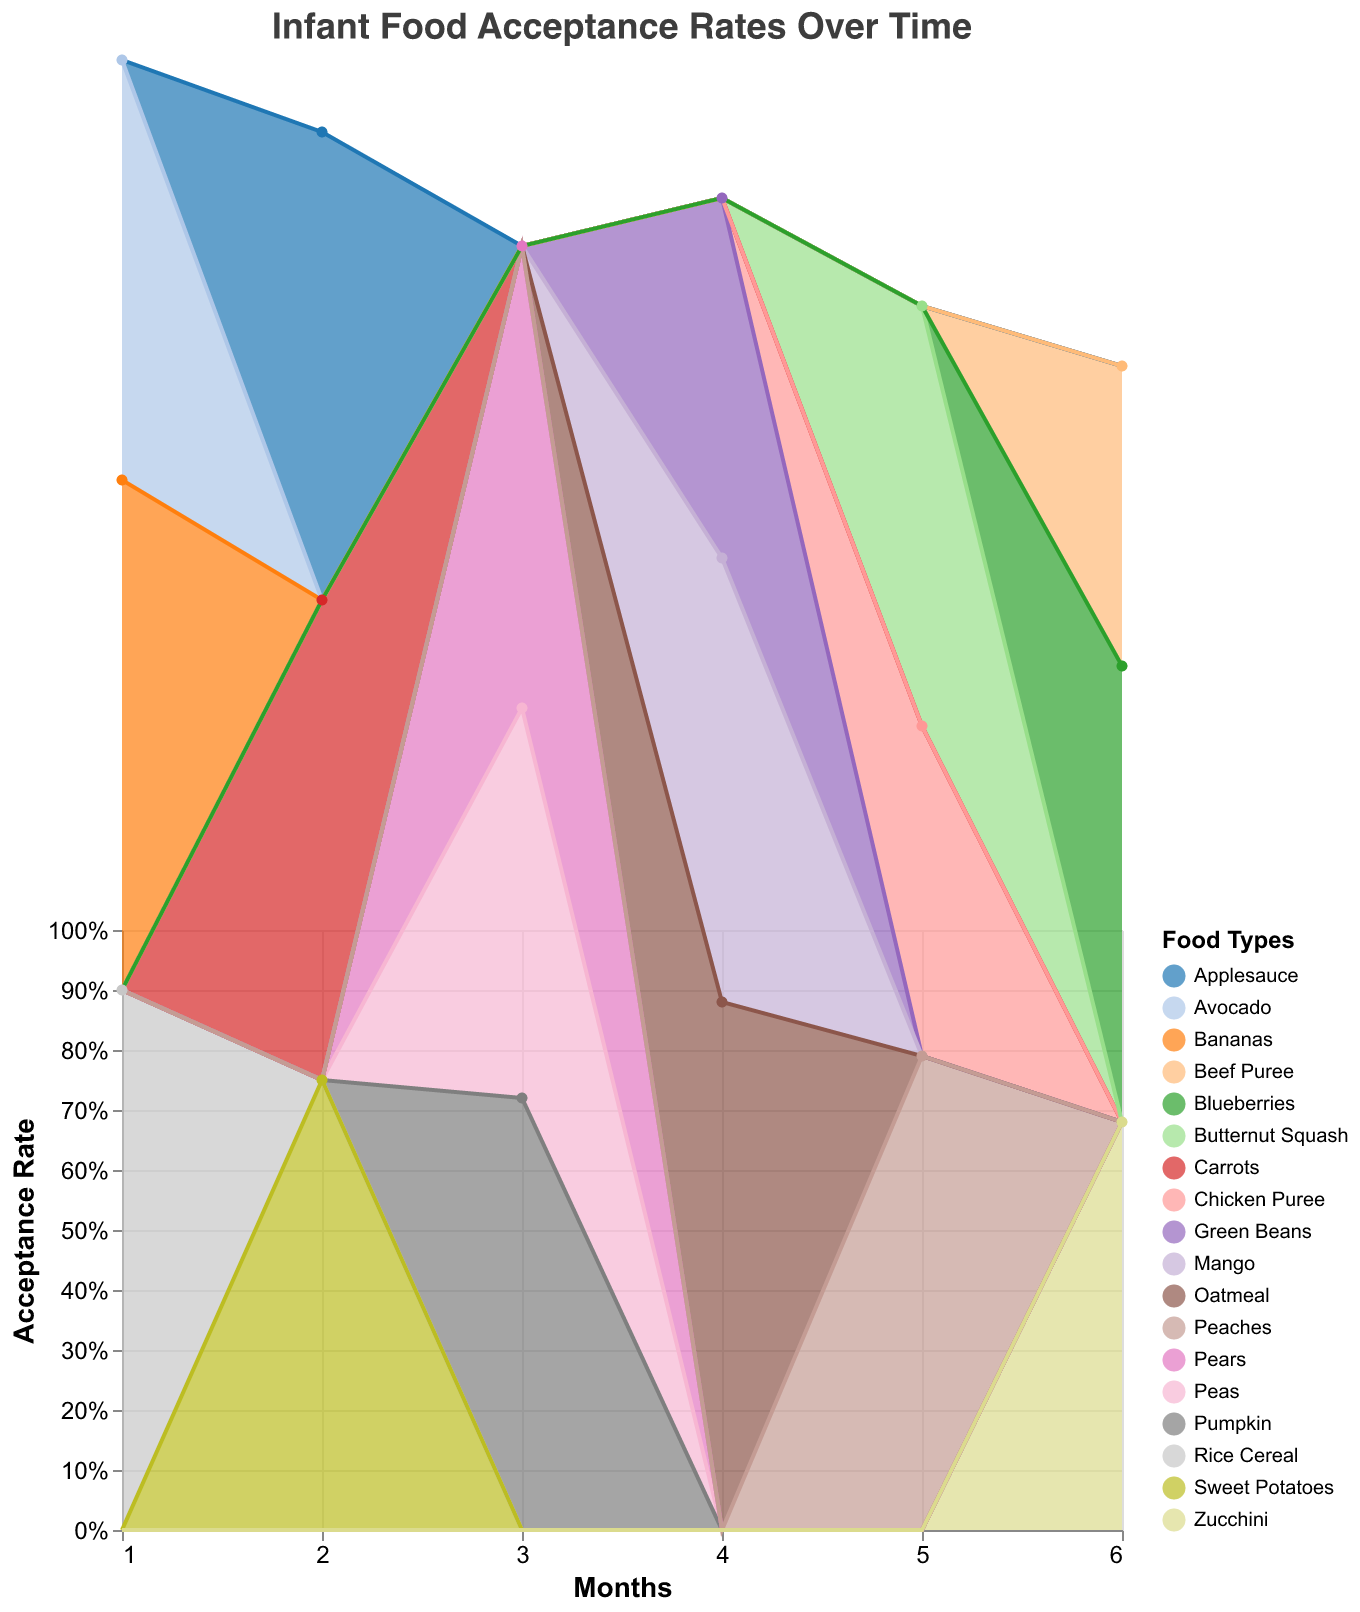What is the title of the chart? The title of the chart is located at the top and is clearly written. It describes the main purpose of the chart.
Answer: Infant Food Acceptance Rates Over Time How many food types are tracked in this chart? Each unique color represents a different food type. By counting the distinct colors or checking the legend, we can determine the number of food types.
Answer: 18 Which food type introduced in the 1st month has the highest acceptance rate? Look at the first month (Month 1) on the x-axis and identify the food type that reaches the highest point on the y-axis.
Answer: Rice Cereal What is the acceptance rate of Pears introduced in the 3rd month? Locate the third month (Month 3) on the x-axis and find the point corresponding to Pears on the y-axis. The tooltip may also help in reading precise values.
Answer: 0.77 Which month has the least variety of new food types introduced? Count the number of distinct food types for each month and find the month with the smallest count.
Answer: Month 6 Compare the acceptance rate of Oatmeal introduced in the 4th month with Avocado introduced in the 1st month. Which has a higher acceptance rate? Locate both food types on their respective months on the x-axis and compare their positions on the y-axis.
Answer: Oatmeal What is the average acceptance rate for the foods introduced in the 2nd month? Sum the acceptance rates of the foods introduced in Month 2 then divide by the number of foods. \( (0.75 + 0.80 + 0.78) / 3 = 0.777 \)
Answer: 0.777 Between Sweet Potatoes introduced in the 2nd month and Green Beans introduced in the 4th month, which has a higher acceptance rate? Locate both food types on their respective months along the x-axis and compare their positions on the y-axis.
Answer: Carrots What is the trend of acceptance rates for the food types introduced over time? Increasing, decreasing or mixed? Observe the general pattern of the lines or areas from left to right. Mixed trends indicate no consistent pattern.
Answer: Mixed What is the combined acceptance rate of Peas, Pumpkin, and Pears introduced in the 3rd month? Sum the acceptance rates for Peas, Pumpkin, and Pears introduced in Month 3. \( 0.65 + 0.72 + 0.77 = 2.14 \)
Answer: 2.14 